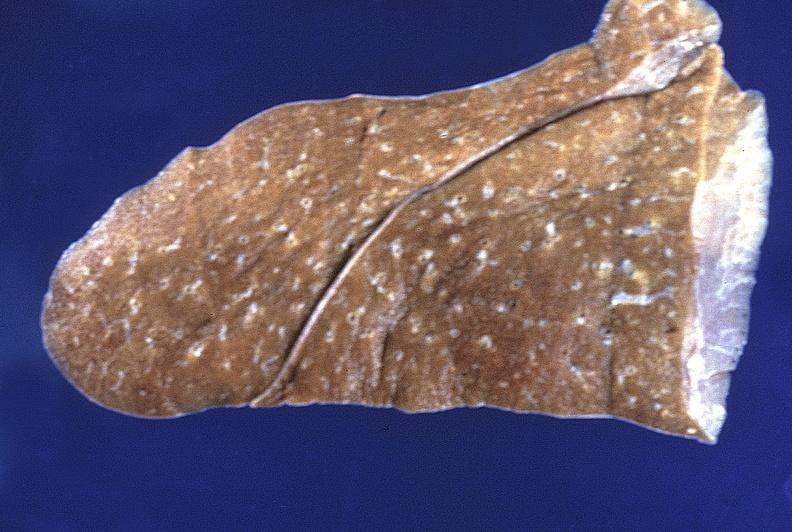what is present?
Answer the question using a single word or phrase. Respiratory 